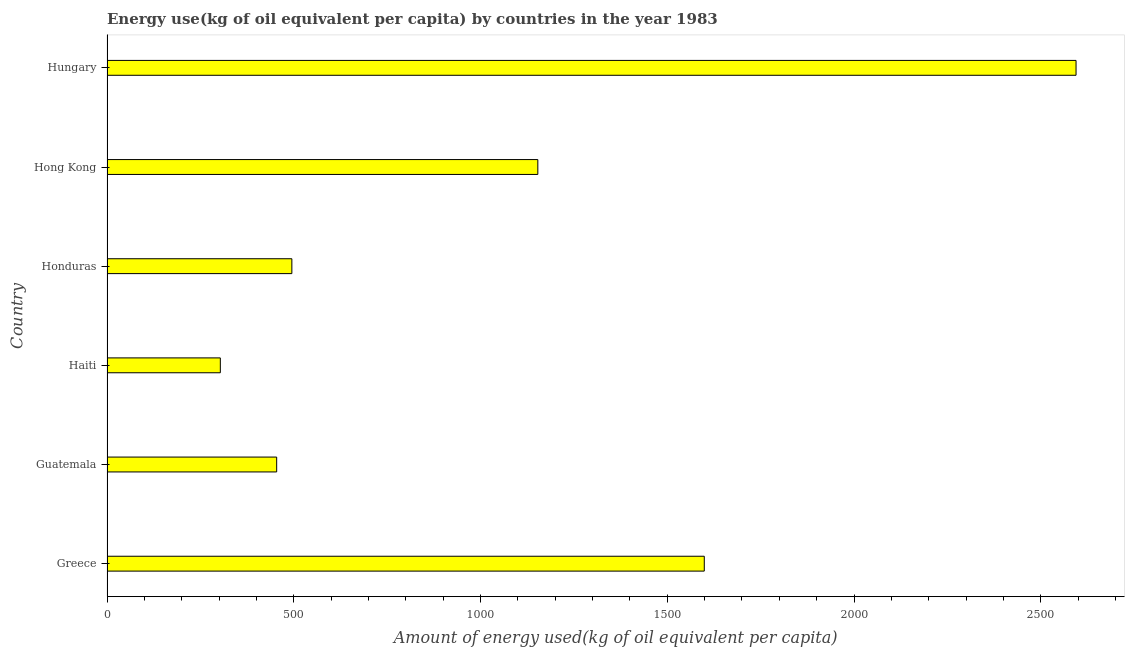Does the graph contain any zero values?
Offer a terse response. No. What is the title of the graph?
Make the answer very short. Energy use(kg of oil equivalent per capita) by countries in the year 1983. What is the label or title of the X-axis?
Offer a terse response. Amount of energy used(kg of oil equivalent per capita). What is the amount of energy used in Honduras?
Your answer should be compact. 494.92. Across all countries, what is the maximum amount of energy used?
Ensure brevity in your answer.  2594.39. Across all countries, what is the minimum amount of energy used?
Ensure brevity in your answer.  303.41. In which country was the amount of energy used maximum?
Give a very brief answer. Hungary. In which country was the amount of energy used minimum?
Offer a terse response. Haiti. What is the sum of the amount of energy used?
Your answer should be compact. 6599.46. What is the difference between the amount of energy used in Hong Kong and Hungary?
Give a very brief answer. -1440.97. What is the average amount of energy used per country?
Provide a short and direct response. 1099.91. What is the median amount of energy used?
Offer a very short reply. 824.17. In how many countries, is the amount of energy used greater than 1400 kg?
Ensure brevity in your answer.  2. What is the ratio of the amount of energy used in Greece to that in Hungary?
Provide a short and direct response. 0.62. Is the amount of energy used in Greece less than that in Guatemala?
Provide a short and direct response. No. What is the difference between the highest and the second highest amount of energy used?
Ensure brevity in your answer.  995.33. What is the difference between the highest and the lowest amount of energy used?
Ensure brevity in your answer.  2290.98. Are all the bars in the graph horizontal?
Your answer should be very brief. Yes. What is the Amount of energy used(kg of oil equivalent per capita) in Greece?
Provide a succinct answer. 1599.07. What is the Amount of energy used(kg of oil equivalent per capita) in Guatemala?
Provide a succinct answer. 454.24. What is the Amount of energy used(kg of oil equivalent per capita) in Haiti?
Ensure brevity in your answer.  303.41. What is the Amount of energy used(kg of oil equivalent per capita) of Honduras?
Provide a short and direct response. 494.92. What is the Amount of energy used(kg of oil equivalent per capita) in Hong Kong?
Your answer should be very brief. 1153.43. What is the Amount of energy used(kg of oil equivalent per capita) in Hungary?
Offer a very short reply. 2594.39. What is the difference between the Amount of energy used(kg of oil equivalent per capita) in Greece and Guatemala?
Your answer should be very brief. 1144.83. What is the difference between the Amount of energy used(kg of oil equivalent per capita) in Greece and Haiti?
Offer a very short reply. 1295.66. What is the difference between the Amount of energy used(kg of oil equivalent per capita) in Greece and Honduras?
Offer a terse response. 1104.15. What is the difference between the Amount of energy used(kg of oil equivalent per capita) in Greece and Hong Kong?
Provide a short and direct response. 445.64. What is the difference between the Amount of energy used(kg of oil equivalent per capita) in Greece and Hungary?
Offer a terse response. -995.32. What is the difference between the Amount of energy used(kg of oil equivalent per capita) in Guatemala and Haiti?
Ensure brevity in your answer.  150.83. What is the difference between the Amount of energy used(kg of oil equivalent per capita) in Guatemala and Honduras?
Your response must be concise. -40.68. What is the difference between the Amount of energy used(kg of oil equivalent per capita) in Guatemala and Hong Kong?
Offer a terse response. -699.19. What is the difference between the Amount of energy used(kg of oil equivalent per capita) in Guatemala and Hungary?
Offer a very short reply. -2140.16. What is the difference between the Amount of energy used(kg of oil equivalent per capita) in Haiti and Honduras?
Your answer should be compact. -191.51. What is the difference between the Amount of energy used(kg of oil equivalent per capita) in Haiti and Hong Kong?
Keep it short and to the point. -850.02. What is the difference between the Amount of energy used(kg of oil equivalent per capita) in Haiti and Hungary?
Provide a succinct answer. -2290.98. What is the difference between the Amount of energy used(kg of oil equivalent per capita) in Honduras and Hong Kong?
Provide a succinct answer. -658.51. What is the difference between the Amount of energy used(kg of oil equivalent per capita) in Honduras and Hungary?
Give a very brief answer. -2099.48. What is the difference between the Amount of energy used(kg of oil equivalent per capita) in Hong Kong and Hungary?
Offer a very short reply. -1440.97. What is the ratio of the Amount of energy used(kg of oil equivalent per capita) in Greece to that in Guatemala?
Provide a succinct answer. 3.52. What is the ratio of the Amount of energy used(kg of oil equivalent per capita) in Greece to that in Haiti?
Offer a very short reply. 5.27. What is the ratio of the Amount of energy used(kg of oil equivalent per capita) in Greece to that in Honduras?
Your answer should be compact. 3.23. What is the ratio of the Amount of energy used(kg of oil equivalent per capita) in Greece to that in Hong Kong?
Ensure brevity in your answer.  1.39. What is the ratio of the Amount of energy used(kg of oil equivalent per capita) in Greece to that in Hungary?
Your answer should be compact. 0.62. What is the ratio of the Amount of energy used(kg of oil equivalent per capita) in Guatemala to that in Haiti?
Your answer should be very brief. 1.5. What is the ratio of the Amount of energy used(kg of oil equivalent per capita) in Guatemala to that in Honduras?
Keep it short and to the point. 0.92. What is the ratio of the Amount of energy used(kg of oil equivalent per capita) in Guatemala to that in Hong Kong?
Offer a terse response. 0.39. What is the ratio of the Amount of energy used(kg of oil equivalent per capita) in Guatemala to that in Hungary?
Offer a very short reply. 0.17. What is the ratio of the Amount of energy used(kg of oil equivalent per capita) in Haiti to that in Honduras?
Give a very brief answer. 0.61. What is the ratio of the Amount of energy used(kg of oil equivalent per capita) in Haiti to that in Hong Kong?
Give a very brief answer. 0.26. What is the ratio of the Amount of energy used(kg of oil equivalent per capita) in Haiti to that in Hungary?
Give a very brief answer. 0.12. What is the ratio of the Amount of energy used(kg of oil equivalent per capita) in Honduras to that in Hong Kong?
Ensure brevity in your answer.  0.43. What is the ratio of the Amount of energy used(kg of oil equivalent per capita) in Honduras to that in Hungary?
Provide a succinct answer. 0.19. What is the ratio of the Amount of energy used(kg of oil equivalent per capita) in Hong Kong to that in Hungary?
Provide a short and direct response. 0.45. 